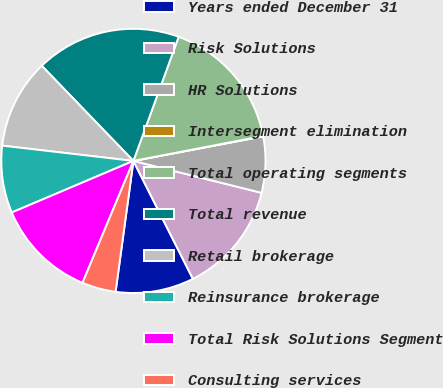Convert chart. <chart><loc_0><loc_0><loc_500><loc_500><pie_chart><fcel>Years ended December 31<fcel>Risk Solutions<fcel>HR Solutions<fcel>Intersegment elimination<fcel>Total operating segments<fcel>Total revenue<fcel>Retail brokerage<fcel>Reinsurance brokerage<fcel>Total Risk Solutions Segment<fcel>Consulting services<nl><fcel>9.59%<fcel>13.68%<fcel>6.86%<fcel>0.05%<fcel>16.41%<fcel>17.77%<fcel>10.95%<fcel>8.23%<fcel>12.32%<fcel>4.14%<nl></chart> 